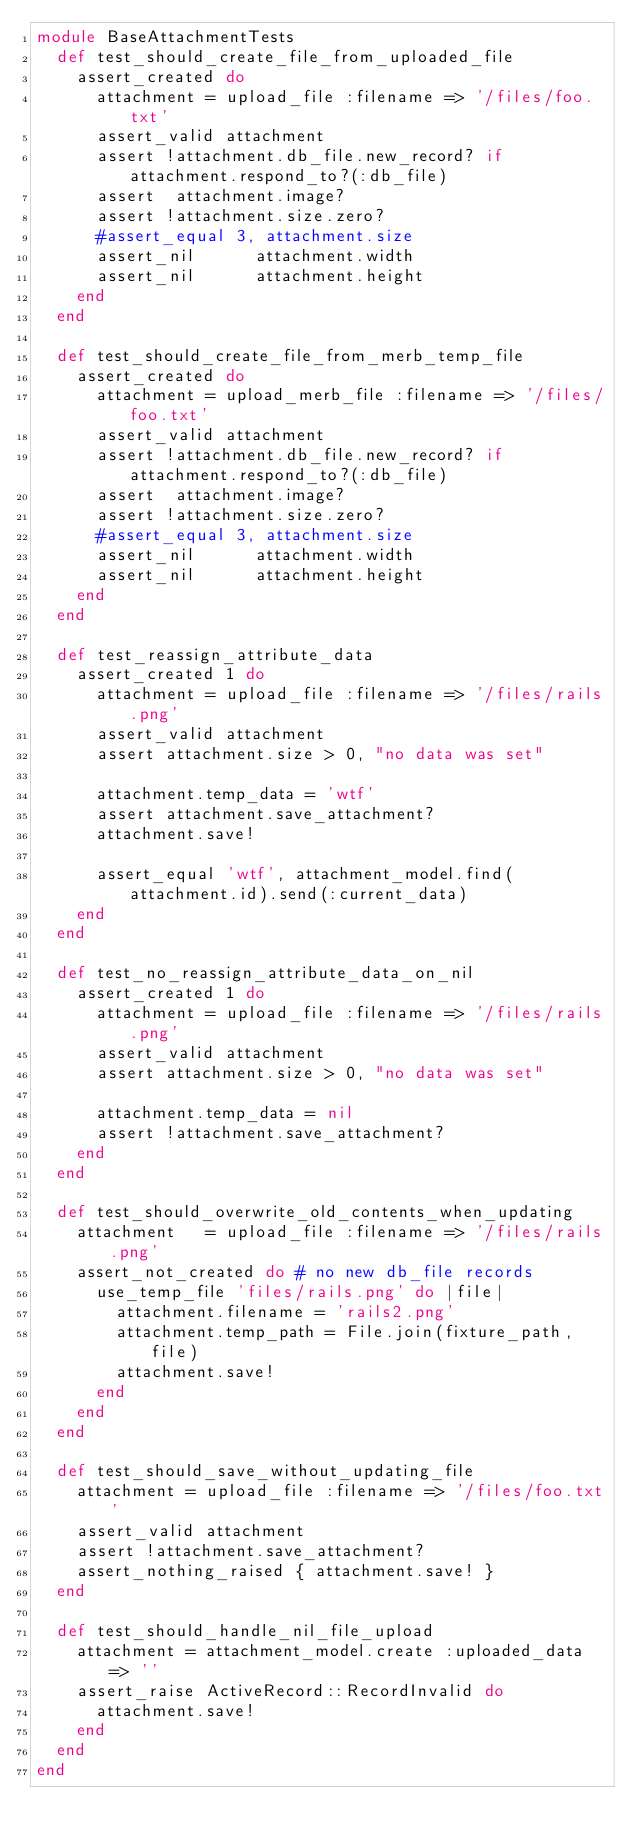<code> <loc_0><loc_0><loc_500><loc_500><_Ruby_>module BaseAttachmentTests
  def test_should_create_file_from_uploaded_file
    assert_created do
      attachment = upload_file :filename => '/files/foo.txt'
      assert_valid attachment
      assert !attachment.db_file.new_record? if attachment.respond_to?(:db_file)
      assert  attachment.image?
      assert !attachment.size.zero?
      #assert_equal 3, attachment.size
      assert_nil      attachment.width
      assert_nil      attachment.height
    end
  end
  
  def test_should_create_file_from_merb_temp_file
    assert_created do
      attachment = upload_merb_file :filename => '/files/foo.txt'
      assert_valid attachment
      assert !attachment.db_file.new_record? if attachment.respond_to?(:db_file)
      assert  attachment.image?
      assert !attachment.size.zero?
      #assert_equal 3, attachment.size
      assert_nil      attachment.width
      assert_nil      attachment.height
    end
  end
  
  def test_reassign_attribute_data
    assert_created 1 do
      attachment = upload_file :filename => '/files/rails.png'
      assert_valid attachment
      assert attachment.size > 0, "no data was set"
      
      attachment.temp_data = 'wtf'
      assert attachment.save_attachment?
      attachment.save!
      
      assert_equal 'wtf', attachment_model.find(attachment.id).send(:current_data)
    end
  end
  
  def test_no_reassign_attribute_data_on_nil
    assert_created 1 do
      attachment = upload_file :filename => '/files/rails.png'
      assert_valid attachment
      assert attachment.size > 0, "no data was set"
      
      attachment.temp_data = nil
      assert !attachment.save_attachment?
    end
  end
  
  def test_should_overwrite_old_contents_when_updating
    attachment   = upload_file :filename => '/files/rails.png'
    assert_not_created do # no new db_file records
      use_temp_file 'files/rails.png' do |file|
        attachment.filename = 'rails2.png'
        attachment.temp_path = File.join(fixture_path, file)
        attachment.save!
      end
    end
  end
  
  def test_should_save_without_updating_file
    attachment = upload_file :filename => '/files/foo.txt'
    assert_valid attachment
    assert !attachment.save_attachment?
    assert_nothing_raised { attachment.save! }
  end
  
  def test_should_handle_nil_file_upload
    attachment = attachment_model.create :uploaded_data => ''
    assert_raise ActiveRecord::RecordInvalid do
      attachment.save!
    end
  end
end</code> 